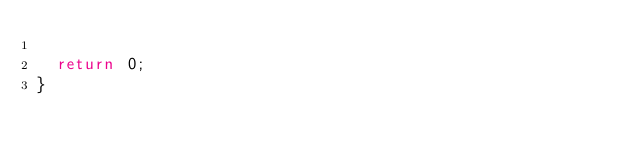<code> <loc_0><loc_0><loc_500><loc_500><_C++_>  
  return 0;
}
</code> 